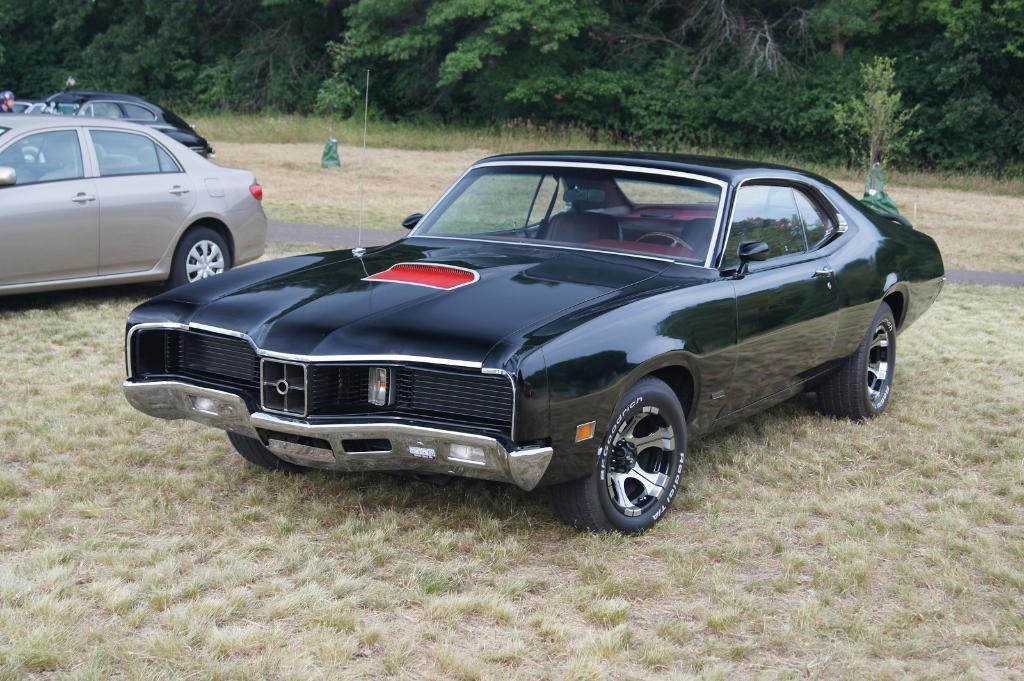Can you describe this image briefly? In this image I can see a car which is black and red in color on the ground and to the left side of the image I can see few other cars on the ground. I can see some grass, the road and few trees in the background. 